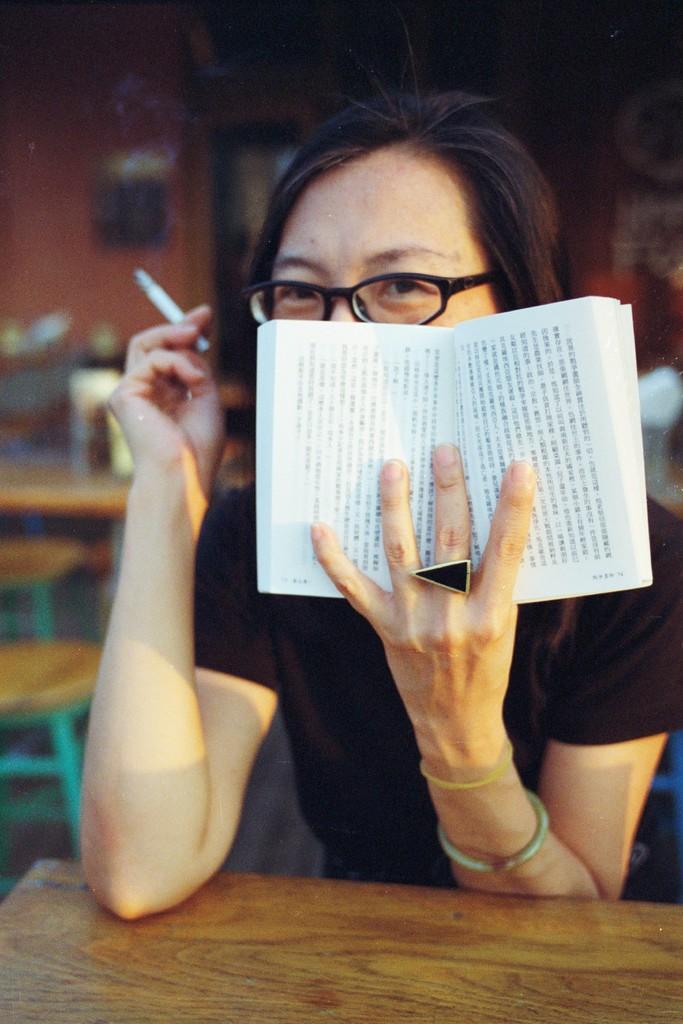Please provide a concise description of this image. In this picture we can observe a person sitting in front of a brown color table and wearing spectacles. This person is holding a book in one hand and a cigarette in the other hand. We can observe a black color T shirt. In the background there are some empty stools and a table. 